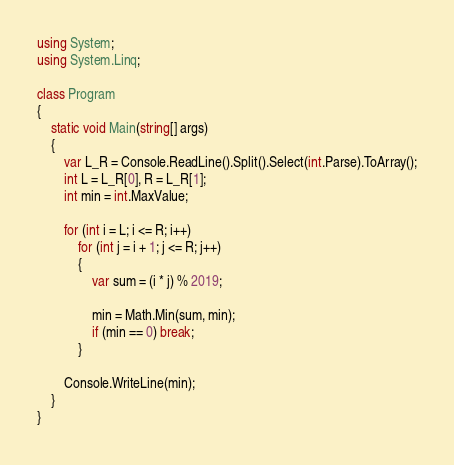<code> <loc_0><loc_0><loc_500><loc_500><_C#_>using System;
using System.Linq;

class Program
{
    static void Main(string[] args)
    {
        var L_R = Console.ReadLine().Split().Select(int.Parse).ToArray();
        int L = L_R[0], R = L_R[1];
        int min = int.MaxValue;

        for (int i = L; i <= R; i++)
            for (int j = i + 1; j <= R; j++)
            {
                var sum = (i * j) % 2019;

                min = Math.Min(sum, min);
                if (min == 0) break;
            }

        Console.WriteLine(min);
    }
}
</code> 